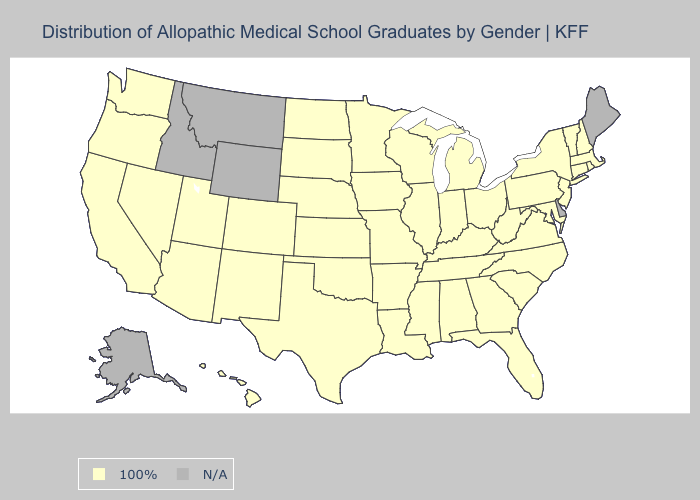Name the states that have a value in the range N/A?
Give a very brief answer. Alaska, Delaware, Idaho, Maine, Montana, Wyoming. Which states have the lowest value in the South?
Give a very brief answer. Alabama, Arkansas, Florida, Georgia, Kentucky, Louisiana, Maryland, Mississippi, North Carolina, Oklahoma, South Carolina, Tennessee, Texas, Virginia, West Virginia. Name the states that have a value in the range N/A?
Answer briefly. Alaska, Delaware, Idaho, Maine, Montana, Wyoming. Name the states that have a value in the range 100%?
Give a very brief answer. Alabama, Arizona, Arkansas, California, Colorado, Connecticut, Florida, Georgia, Hawaii, Illinois, Indiana, Iowa, Kansas, Kentucky, Louisiana, Maryland, Massachusetts, Michigan, Minnesota, Mississippi, Missouri, Nebraska, Nevada, New Hampshire, New Jersey, New Mexico, New York, North Carolina, North Dakota, Ohio, Oklahoma, Oregon, Pennsylvania, Rhode Island, South Carolina, South Dakota, Tennessee, Texas, Utah, Vermont, Virginia, Washington, West Virginia, Wisconsin. Name the states that have a value in the range 100%?
Answer briefly. Alabama, Arizona, Arkansas, California, Colorado, Connecticut, Florida, Georgia, Hawaii, Illinois, Indiana, Iowa, Kansas, Kentucky, Louisiana, Maryland, Massachusetts, Michigan, Minnesota, Mississippi, Missouri, Nebraska, Nevada, New Hampshire, New Jersey, New Mexico, New York, North Carolina, North Dakota, Ohio, Oklahoma, Oregon, Pennsylvania, Rhode Island, South Carolina, South Dakota, Tennessee, Texas, Utah, Vermont, Virginia, Washington, West Virginia, Wisconsin. What is the value of Kansas?
Be succinct. 100%. Name the states that have a value in the range N/A?
Quick response, please. Alaska, Delaware, Idaho, Maine, Montana, Wyoming. Name the states that have a value in the range 100%?
Concise answer only. Alabama, Arizona, Arkansas, California, Colorado, Connecticut, Florida, Georgia, Hawaii, Illinois, Indiana, Iowa, Kansas, Kentucky, Louisiana, Maryland, Massachusetts, Michigan, Minnesota, Mississippi, Missouri, Nebraska, Nevada, New Hampshire, New Jersey, New Mexico, New York, North Carolina, North Dakota, Ohio, Oklahoma, Oregon, Pennsylvania, Rhode Island, South Carolina, South Dakota, Tennessee, Texas, Utah, Vermont, Virginia, Washington, West Virginia, Wisconsin. What is the highest value in states that border Wyoming?
Answer briefly. 100%. Name the states that have a value in the range 100%?
Concise answer only. Alabama, Arizona, Arkansas, California, Colorado, Connecticut, Florida, Georgia, Hawaii, Illinois, Indiana, Iowa, Kansas, Kentucky, Louisiana, Maryland, Massachusetts, Michigan, Minnesota, Mississippi, Missouri, Nebraska, Nevada, New Hampshire, New Jersey, New Mexico, New York, North Carolina, North Dakota, Ohio, Oklahoma, Oregon, Pennsylvania, Rhode Island, South Carolina, South Dakota, Tennessee, Texas, Utah, Vermont, Virginia, Washington, West Virginia, Wisconsin. Name the states that have a value in the range N/A?
Keep it brief. Alaska, Delaware, Idaho, Maine, Montana, Wyoming. 